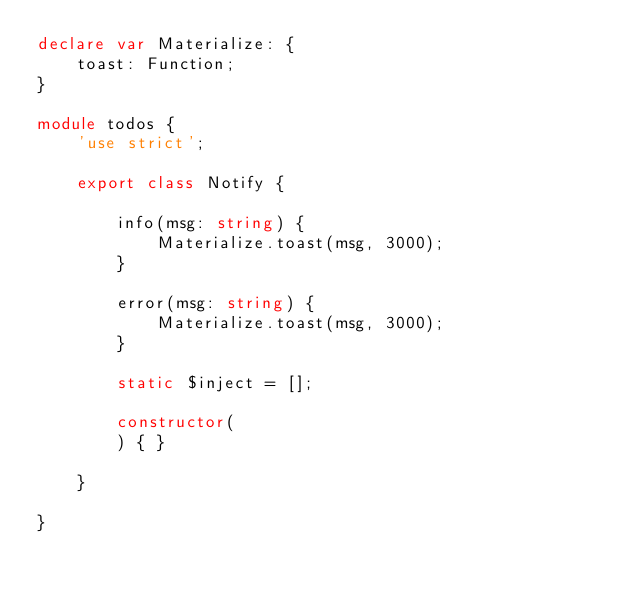<code> <loc_0><loc_0><loc_500><loc_500><_TypeScript_>declare var Materialize: {
    toast: Function;
}

module todos {
    'use strict';

    export class Notify {

        info(msg: string) {
            Materialize.toast(msg, 3000);
        }

        error(msg: string) {
            Materialize.toast(msg, 3000);
        }

        static $inject = [];

        constructor(
        ) { }

    }

}
</code> 